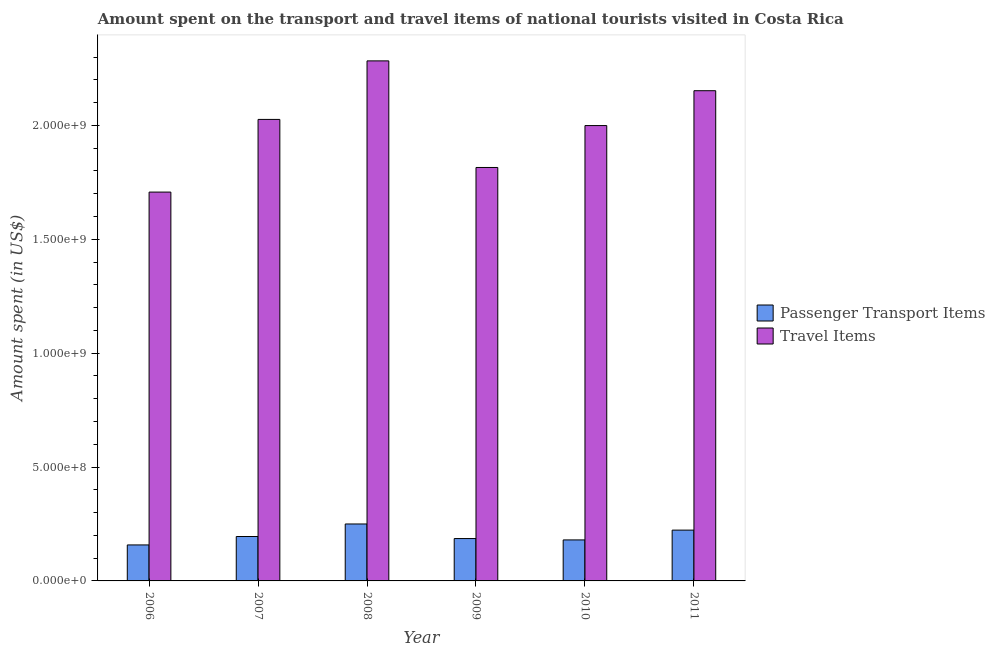How many groups of bars are there?
Give a very brief answer. 6. Are the number of bars per tick equal to the number of legend labels?
Keep it short and to the point. Yes. Are the number of bars on each tick of the X-axis equal?
Keep it short and to the point. Yes. How many bars are there on the 5th tick from the left?
Your response must be concise. 2. What is the label of the 4th group of bars from the left?
Offer a very short reply. 2009. What is the amount spent on passenger transport items in 2006?
Your answer should be very brief. 1.58e+08. Across all years, what is the maximum amount spent in travel items?
Ensure brevity in your answer.  2.28e+09. Across all years, what is the minimum amount spent on passenger transport items?
Give a very brief answer. 1.58e+08. What is the total amount spent on passenger transport items in the graph?
Keep it short and to the point. 1.19e+09. What is the difference between the amount spent on passenger transport items in 2006 and that in 2009?
Offer a very short reply. -2.80e+07. What is the difference between the amount spent on passenger transport items in 2010 and the amount spent in travel items in 2007?
Ensure brevity in your answer.  -1.50e+07. What is the average amount spent on passenger transport items per year?
Ensure brevity in your answer.  1.99e+08. What is the ratio of the amount spent in travel items in 2006 to that in 2008?
Your answer should be compact. 0.75. What is the difference between the highest and the second highest amount spent on passenger transport items?
Offer a terse response. 2.70e+07. What is the difference between the highest and the lowest amount spent on passenger transport items?
Your response must be concise. 9.20e+07. In how many years, is the amount spent in travel items greater than the average amount spent in travel items taken over all years?
Provide a succinct answer. 4. Is the sum of the amount spent on passenger transport items in 2009 and 2010 greater than the maximum amount spent in travel items across all years?
Your response must be concise. Yes. What does the 2nd bar from the left in 2006 represents?
Make the answer very short. Travel Items. What does the 1st bar from the right in 2007 represents?
Your answer should be compact. Travel Items. Does the graph contain any zero values?
Your response must be concise. No. How are the legend labels stacked?
Your answer should be compact. Vertical. What is the title of the graph?
Provide a short and direct response. Amount spent on the transport and travel items of national tourists visited in Costa Rica. What is the label or title of the X-axis?
Your answer should be compact. Year. What is the label or title of the Y-axis?
Provide a short and direct response. Amount spent (in US$). What is the Amount spent (in US$) in Passenger Transport Items in 2006?
Your answer should be very brief. 1.58e+08. What is the Amount spent (in US$) of Travel Items in 2006?
Make the answer very short. 1.71e+09. What is the Amount spent (in US$) in Passenger Transport Items in 2007?
Provide a short and direct response. 1.95e+08. What is the Amount spent (in US$) in Travel Items in 2007?
Your response must be concise. 2.03e+09. What is the Amount spent (in US$) in Passenger Transport Items in 2008?
Your answer should be compact. 2.50e+08. What is the Amount spent (in US$) in Travel Items in 2008?
Provide a short and direct response. 2.28e+09. What is the Amount spent (in US$) in Passenger Transport Items in 2009?
Offer a terse response. 1.86e+08. What is the Amount spent (in US$) in Travel Items in 2009?
Ensure brevity in your answer.  1.82e+09. What is the Amount spent (in US$) of Passenger Transport Items in 2010?
Your answer should be very brief. 1.80e+08. What is the Amount spent (in US$) of Travel Items in 2010?
Your answer should be very brief. 2.00e+09. What is the Amount spent (in US$) of Passenger Transport Items in 2011?
Ensure brevity in your answer.  2.23e+08. What is the Amount spent (in US$) in Travel Items in 2011?
Keep it short and to the point. 2.15e+09. Across all years, what is the maximum Amount spent (in US$) in Passenger Transport Items?
Your answer should be compact. 2.50e+08. Across all years, what is the maximum Amount spent (in US$) of Travel Items?
Give a very brief answer. 2.28e+09. Across all years, what is the minimum Amount spent (in US$) of Passenger Transport Items?
Ensure brevity in your answer.  1.58e+08. Across all years, what is the minimum Amount spent (in US$) in Travel Items?
Your answer should be very brief. 1.71e+09. What is the total Amount spent (in US$) in Passenger Transport Items in the graph?
Ensure brevity in your answer.  1.19e+09. What is the total Amount spent (in US$) of Travel Items in the graph?
Give a very brief answer. 1.20e+1. What is the difference between the Amount spent (in US$) in Passenger Transport Items in 2006 and that in 2007?
Give a very brief answer. -3.70e+07. What is the difference between the Amount spent (in US$) in Travel Items in 2006 and that in 2007?
Keep it short and to the point. -3.19e+08. What is the difference between the Amount spent (in US$) of Passenger Transport Items in 2006 and that in 2008?
Your answer should be compact. -9.20e+07. What is the difference between the Amount spent (in US$) in Travel Items in 2006 and that in 2008?
Ensure brevity in your answer.  -5.76e+08. What is the difference between the Amount spent (in US$) in Passenger Transport Items in 2006 and that in 2009?
Ensure brevity in your answer.  -2.80e+07. What is the difference between the Amount spent (in US$) of Travel Items in 2006 and that in 2009?
Provide a short and direct response. -1.08e+08. What is the difference between the Amount spent (in US$) of Passenger Transport Items in 2006 and that in 2010?
Keep it short and to the point. -2.20e+07. What is the difference between the Amount spent (in US$) of Travel Items in 2006 and that in 2010?
Your answer should be very brief. -2.92e+08. What is the difference between the Amount spent (in US$) in Passenger Transport Items in 2006 and that in 2011?
Offer a very short reply. -6.50e+07. What is the difference between the Amount spent (in US$) in Travel Items in 2006 and that in 2011?
Ensure brevity in your answer.  -4.45e+08. What is the difference between the Amount spent (in US$) of Passenger Transport Items in 2007 and that in 2008?
Provide a short and direct response. -5.50e+07. What is the difference between the Amount spent (in US$) in Travel Items in 2007 and that in 2008?
Make the answer very short. -2.57e+08. What is the difference between the Amount spent (in US$) of Passenger Transport Items in 2007 and that in 2009?
Ensure brevity in your answer.  9.00e+06. What is the difference between the Amount spent (in US$) of Travel Items in 2007 and that in 2009?
Offer a very short reply. 2.11e+08. What is the difference between the Amount spent (in US$) of Passenger Transport Items in 2007 and that in 2010?
Your answer should be compact. 1.50e+07. What is the difference between the Amount spent (in US$) in Travel Items in 2007 and that in 2010?
Make the answer very short. 2.70e+07. What is the difference between the Amount spent (in US$) of Passenger Transport Items in 2007 and that in 2011?
Make the answer very short. -2.80e+07. What is the difference between the Amount spent (in US$) of Travel Items in 2007 and that in 2011?
Offer a very short reply. -1.26e+08. What is the difference between the Amount spent (in US$) of Passenger Transport Items in 2008 and that in 2009?
Your answer should be compact. 6.40e+07. What is the difference between the Amount spent (in US$) of Travel Items in 2008 and that in 2009?
Offer a terse response. 4.68e+08. What is the difference between the Amount spent (in US$) of Passenger Transport Items in 2008 and that in 2010?
Your response must be concise. 7.00e+07. What is the difference between the Amount spent (in US$) of Travel Items in 2008 and that in 2010?
Your answer should be compact. 2.84e+08. What is the difference between the Amount spent (in US$) in Passenger Transport Items in 2008 and that in 2011?
Keep it short and to the point. 2.70e+07. What is the difference between the Amount spent (in US$) of Travel Items in 2008 and that in 2011?
Offer a terse response. 1.31e+08. What is the difference between the Amount spent (in US$) of Passenger Transport Items in 2009 and that in 2010?
Provide a succinct answer. 6.00e+06. What is the difference between the Amount spent (in US$) in Travel Items in 2009 and that in 2010?
Your answer should be very brief. -1.84e+08. What is the difference between the Amount spent (in US$) of Passenger Transport Items in 2009 and that in 2011?
Keep it short and to the point. -3.70e+07. What is the difference between the Amount spent (in US$) of Travel Items in 2009 and that in 2011?
Offer a terse response. -3.37e+08. What is the difference between the Amount spent (in US$) in Passenger Transport Items in 2010 and that in 2011?
Your answer should be very brief. -4.30e+07. What is the difference between the Amount spent (in US$) of Travel Items in 2010 and that in 2011?
Offer a very short reply. -1.53e+08. What is the difference between the Amount spent (in US$) of Passenger Transport Items in 2006 and the Amount spent (in US$) of Travel Items in 2007?
Make the answer very short. -1.87e+09. What is the difference between the Amount spent (in US$) of Passenger Transport Items in 2006 and the Amount spent (in US$) of Travel Items in 2008?
Ensure brevity in your answer.  -2.12e+09. What is the difference between the Amount spent (in US$) of Passenger Transport Items in 2006 and the Amount spent (in US$) of Travel Items in 2009?
Provide a short and direct response. -1.66e+09. What is the difference between the Amount spent (in US$) of Passenger Transport Items in 2006 and the Amount spent (in US$) of Travel Items in 2010?
Your response must be concise. -1.84e+09. What is the difference between the Amount spent (in US$) in Passenger Transport Items in 2006 and the Amount spent (in US$) in Travel Items in 2011?
Offer a terse response. -1.99e+09. What is the difference between the Amount spent (in US$) of Passenger Transport Items in 2007 and the Amount spent (in US$) of Travel Items in 2008?
Provide a short and direct response. -2.09e+09. What is the difference between the Amount spent (in US$) in Passenger Transport Items in 2007 and the Amount spent (in US$) in Travel Items in 2009?
Give a very brief answer. -1.62e+09. What is the difference between the Amount spent (in US$) in Passenger Transport Items in 2007 and the Amount spent (in US$) in Travel Items in 2010?
Your answer should be compact. -1.80e+09. What is the difference between the Amount spent (in US$) of Passenger Transport Items in 2007 and the Amount spent (in US$) of Travel Items in 2011?
Your answer should be very brief. -1.96e+09. What is the difference between the Amount spent (in US$) of Passenger Transport Items in 2008 and the Amount spent (in US$) of Travel Items in 2009?
Provide a succinct answer. -1.56e+09. What is the difference between the Amount spent (in US$) in Passenger Transport Items in 2008 and the Amount spent (in US$) in Travel Items in 2010?
Keep it short and to the point. -1.75e+09. What is the difference between the Amount spent (in US$) in Passenger Transport Items in 2008 and the Amount spent (in US$) in Travel Items in 2011?
Offer a terse response. -1.90e+09. What is the difference between the Amount spent (in US$) of Passenger Transport Items in 2009 and the Amount spent (in US$) of Travel Items in 2010?
Offer a very short reply. -1.81e+09. What is the difference between the Amount spent (in US$) in Passenger Transport Items in 2009 and the Amount spent (in US$) in Travel Items in 2011?
Ensure brevity in your answer.  -1.97e+09. What is the difference between the Amount spent (in US$) in Passenger Transport Items in 2010 and the Amount spent (in US$) in Travel Items in 2011?
Give a very brief answer. -1.97e+09. What is the average Amount spent (in US$) of Passenger Transport Items per year?
Offer a very short reply. 1.99e+08. What is the average Amount spent (in US$) of Travel Items per year?
Keep it short and to the point. 2.00e+09. In the year 2006, what is the difference between the Amount spent (in US$) in Passenger Transport Items and Amount spent (in US$) in Travel Items?
Ensure brevity in your answer.  -1.55e+09. In the year 2007, what is the difference between the Amount spent (in US$) of Passenger Transport Items and Amount spent (in US$) of Travel Items?
Provide a succinct answer. -1.83e+09. In the year 2008, what is the difference between the Amount spent (in US$) in Passenger Transport Items and Amount spent (in US$) in Travel Items?
Your response must be concise. -2.03e+09. In the year 2009, what is the difference between the Amount spent (in US$) of Passenger Transport Items and Amount spent (in US$) of Travel Items?
Make the answer very short. -1.63e+09. In the year 2010, what is the difference between the Amount spent (in US$) of Passenger Transport Items and Amount spent (in US$) of Travel Items?
Provide a short and direct response. -1.82e+09. In the year 2011, what is the difference between the Amount spent (in US$) in Passenger Transport Items and Amount spent (in US$) in Travel Items?
Your answer should be very brief. -1.93e+09. What is the ratio of the Amount spent (in US$) of Passenger Transport Items in 2006 to that in 2007?
Offer a terse response. 0.81. What is the ratio of the Amount spent (in US$) in Travel Items in 2006 to that in 2007?
Offer a terse response. 0.84. What is the ratio of the Amount spent (in US$) of Passenger Transport Items in 2006 to that in 2008?
Provide a succinct answer. 0.63. What is the ratio of the Amount spent (in US$) of Travel Items in 2006 to that in 2008?
Offer a terse response. 0.75. What is the ratio of the Amount spent (in US$) in Passenger Transport Items in 2006 to that in 2009?
Your answer should be very brief. 0.85. What is the ratio of the Amount spent (in US$) in Travel Items in 2006 to that in 2009?
Give a very brief answer. 0.94. What is the ratio of the Amount spent (in US$) in Passenger Transport Items in 2006 to that in 2010?
Your response must be concise. 0.88. What is the ratio of the Amount spent (in US$) of Travel Items in 2006 to that in 2010?
Ensure brevity in your answer.  0.85. What is the ratio of the Amount spent (in US$) in Passenger Transport Items in 2006 to that in 2011?
Your response must be concise. 0.71. What is the ratio of the Amount spent (in US$) in Travel Items in 2006 to that in 2011?
Ensure brevity in your answer.  0.79. What is the ratio of the Amount spent (in US$) of Passenger Transport Items in 2007 to that in 2008?
Offer a terse response. 0.78. What is the ratio of the Amount spent (in US$) of Travel Items in 2007 to that in 2008?
Provide a short and direct response. 0.89. What is the ratio of the Amount spent (in US$) of Passenger Transport Items in 2007 to that in 2009?
Provide a short and direct response. 1.05. What is the ratio of the Amount spent (in US$) of Travel Items in 2007 to that in 2009?
Keep it short and to the point. 1.12. What is the ratio of the Amount spent (in US$) of Travel Items in 2007 to that in 2010?
Your answer should be very brief. 1.01. What is the ratio of the Amount spent (in US$) in Passenger Transport Items in 2007 to that in 2011?
Your answer should be compact. 0.87. What is the ratio of the Amount spent (in US$) in Travel Items in 2007 to that in 2011?
Provide a succinct answer. 0.94. What is the ratio of the Amount spent (in US$) in Passenger Transport Items in 2008 to that in 2009?
Provide a short and direct response. 1.34. What is the ratio of the Amount spent (in US$) in Travel Items in 2008 to that in 2009?
Make the answer very short. 1.26. What is the ratio of the Amount spent (in US$) in Passenger Transport Items in 2008 to that in 2010?
Your answer should be very brief. 1.39. What is the ratio of the Amount spent (in US$) in Travel Items in 2008 to that in 2010?
Provide a succinct answer. 1.14. What is the ratio of the Amount spent (in US$) in Passenger Transport Items in 2008 to that in 2011?
Your answer should be very brief. 1.12. What is the ratio of the Amount spent (in US$) in Travel Items in 2008 to that in 2011?
Offer a very short reply. 1.06. What is the ratio of the Amount spent (in US$) in Travel Items in 2009 to that in 2010?
Keep it short and to the point. 0.91. What is the ratio of the Amount spent (in US$) of Passenger Transport Items in 2009 to that in 2011?
Provide a short and direct response. 0.83. What is the ratio of the Amount spent (in US$) in Travel Items in 2009 to that in 2011?
Make the answer very short. 0.84. What is the ratio of the Amount spent (in US$) in Passenger Transport Items in 2010 to that in 2011?
Keep it short and to the point. 0.81. What is the ratio of the Amount spent (in US$) of Travel Items in 2010 to that in 2011?
Your answer should be very brief. 0.93. What is the difference between the highest and the second highest Amount spent (in US$) of Passenger Transport Items?
Keep it short and to the point. 2.70e+07. What is the difference between the highest and the second highest Amount spent (in US$) of Travel Items?
Provide a succinct answer. 1.31e+08. What is the difference between the highest and the lowest Amount spent (in US$) of Passenger Transport Items?
Provide a succinct answer. 9.20e+07. What is the difference between the highest and the lowest Amount spent (in US$) of Travel Items?
Provide a succinct answer. 5.76e+08. 